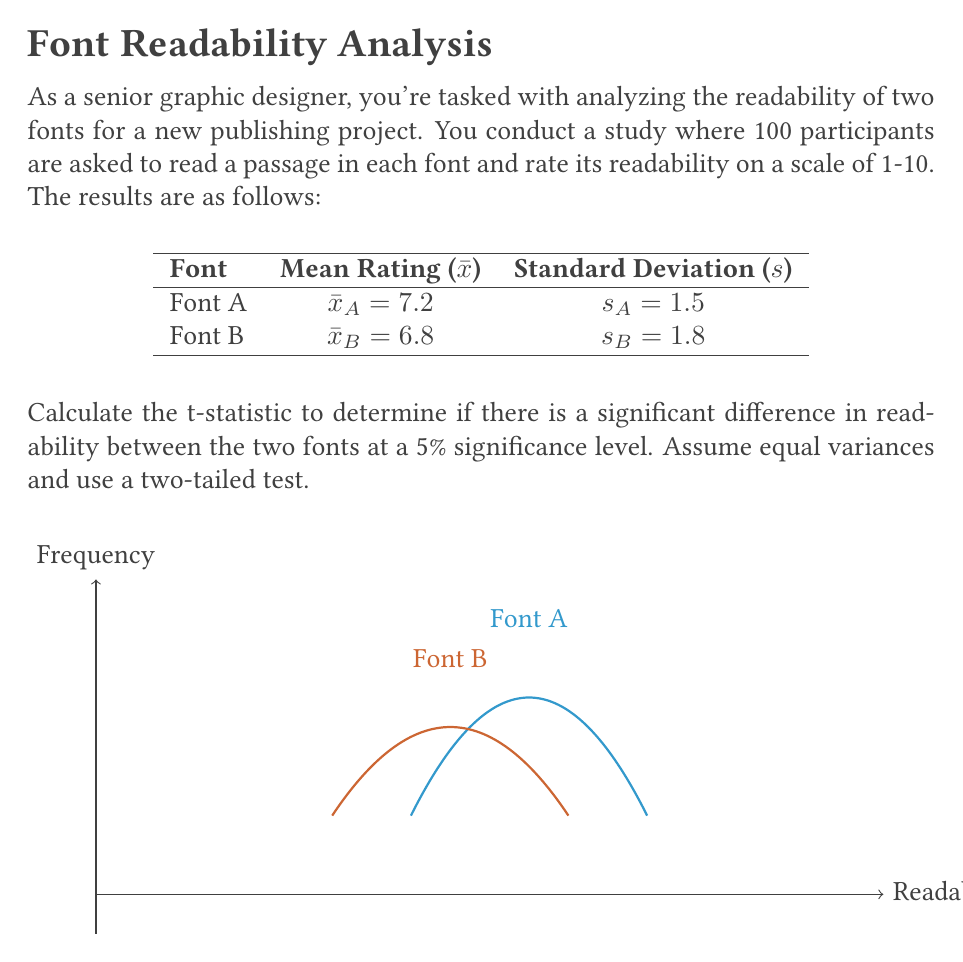Could you help me with this problem? To calculate the t-statistic, we'll follow these steps:

1) The formula for the t-statistic with equal variances is:

   $$t = \frac{\bar{x}_A - \bar{x}_B}{s_p \sqrt{\frac{2}{n}}}$$

   where $s_p$ is the pooled standard deviation and $n$ is the sample size for each group.

2) Calculate the pooled standard deviation:

   $$s_p = \sqrt{\frac{(n_A - 1)s_A^2 + (n_B - 1)s_B^2}{n_A + n_B - 2}}$$
   
   $$s_p = \sqrt{\frac{(100 - 1)(1.5)^2 + (100 - 1)(1.8)^2}{100 + 100 - 2}}$$
   
   $$s_p = \sqrt{\frac{99(2.25) + 99(3.24)}{198}} = \sqrt{\frac{222.75 + 320.76}{198}} = \sqrt{2.745} = 1.657$$

3) Now, we can calculate the t-statistic:

   $$t = \frac{7.2 - 6.8}{1.657 \sqrt{\frac{2}{100}}} = \frac{0.4}{1.657 \sqrt{0.02}} = \frac{0.4}{0.234} = 1.709$$

4) To determine significance, we compare this to the critical t-value for a two-tailed test at 5% significance level with degrees of freedom $df = n_A + n_B - 2 = 198$.

   The critical t-value for df = 198 and α = 0.05 (two-tailed) is approximately 1.972.

5) Since our calculated t-statistic (1.709) is less than the critical value (1.972), we fail to reject the null hypothesis.
Answer: t = 1.709; not significant at α = 0.05 